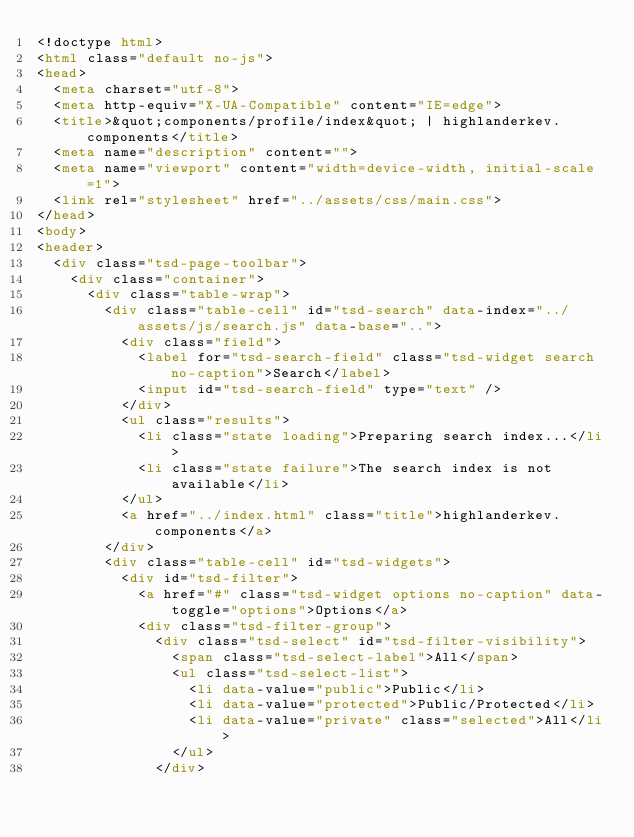<code> <loc_0><loc_0><loc_500><loc_500><_HTML_><!doctype html>
<html class="default no-js">
<head>
	<meta charset="utf-8">
	<meta http-equiv="X-UA-Compatible" content="IE=edge">
	<title>&quot;components/profile/index&quot; | highlanderkev.components</title>
	<meta name="description" content="">
	<meta name="viewport" content="width=device-width, initial-scale=1">
	<link rel="stylesheet" href="../assets/css/main.css">
</head>
<body>
<header>
	<div class="tsd-page-toolbar">
		<div class="container">
			<div class="table-wrap">
				<div class="table-cell" id="tsd-search" data-index="../assets/js/search.js" data-base="..">
					<div class="field">
						<label for="tsd-search-field" class="tsd-widget search no-caption">Search</label>
						<input id="tsd-search-field" type="text" />
					</div>
					<ul class="results">
						<li class="state loading">Preparing search index...</li>
						<li class="state failure">The search index is not available</li>
					</ul>
					<a href="../index.html" class="title">highlanderkev.components</a>
				</div>
				<div class="table-cell" id="tsd-widgets">
					<div id="tsd-filter">
						<a href="#" class="tsd-widget options no-caption" data-toggle="options">Options</a>
						<div class="tsd-filter-group">
							<div class="tsd-select" id="tsd-filter-visibility">
								<span class="tsd-select-label">All</span>
								<ul class="tsd-select-list">
									<li data-value="public">Public</li>
									<li data-value="protected">Public/Protected</li>
									<li data-value="private" class="selected">All</li>
								</ul>
							</div></code> 